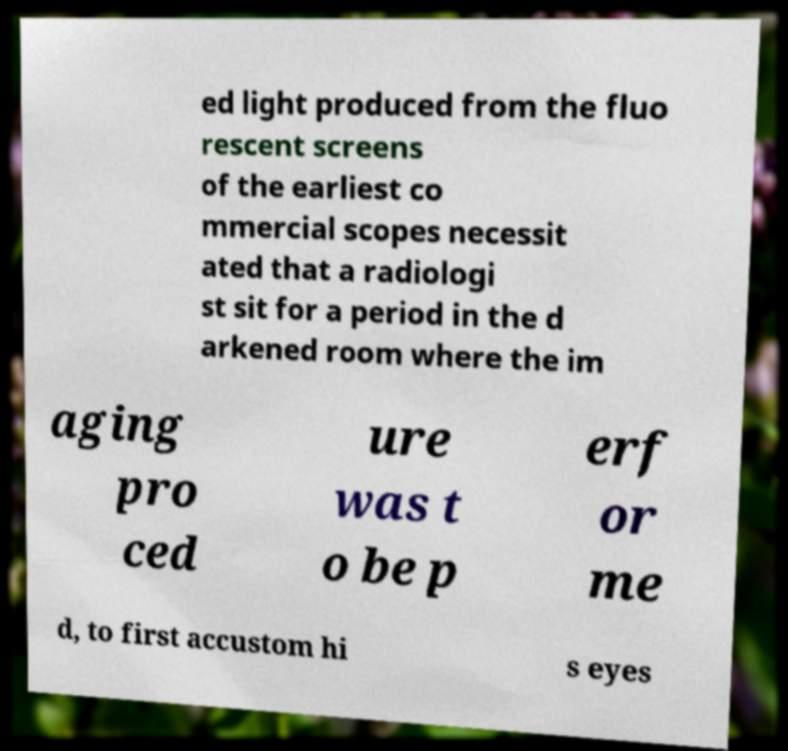Please identify and transcribe the text found in this image. ed light produced from the fluo rescent screens of the earliest co mmercial scopes necessit ated that a radiologi st sit for a period in the d arkened room where the im aging pro ced ure was t o be p erf or me d, to first accustom hi s eyes 